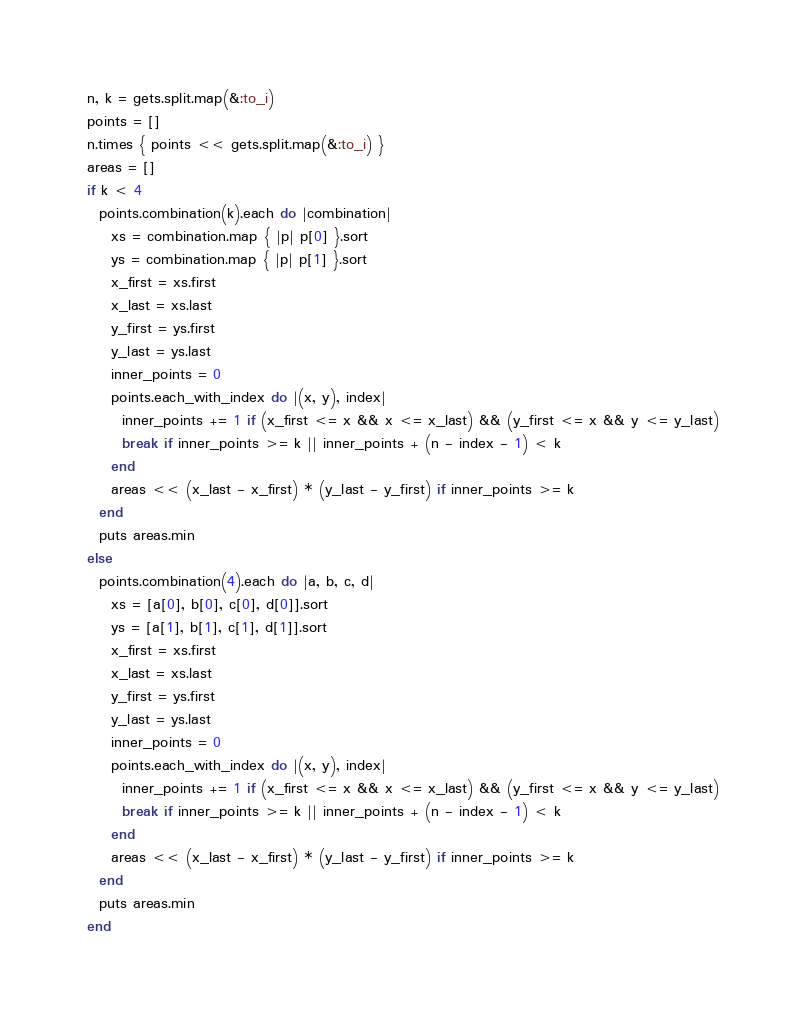<code> <loc_0><loc_0><loc_500><loc_500><_Ruby_>n, k = gets.split.map(&:to_i)
points = []
n.times { points << gets.split.map(&:to_i) }
areas = []
if k < 4
  points.combination(k).each do |combination|
    xs = combination.map { |p| p[0] }.sort
    ys = combination.map { |p| p[1] }.sort
    x_first = xs.first
    x_last = xs.last
    y_first = ys.first
    y_last = ys.last
    inner_points = 0
    points.each_with_index do |(x, y), index|
      inner_points += 1 if (x_first <= x && x <= x_last) && (y_first <= x && y <= y_last)
      break if inner_points >= k || inner_points + (n - index - 1) < k
    end
    areas << (x_last - x_first) * (y_last - y_first) if inner_points >= k
  end
  puts areas.min
else
  points.combination(4).each do |a, b, c, d|
    xs = [a[0], b[0], c[0], d[0]].sort
    ys = [a[1], b[1], c[1], d[1]].sort
    x_first = xs.first
    x_last = xs.last
    y_first = ys.first
    y_last = ys.last
    inner_points = 0
    points.each_with_index do |(x, y), index|
      inner_points += 1 if (x_first <= x && x <= x_last) && (y_first <= x && y <= y_last)
      break if inner_points >= k || inner_points + (n - index - 1) < k
    end
    areas << (x_last - x_first) * (y_last - y_first) if inner_points >= k
  end
  puts areas.min
end</code> 